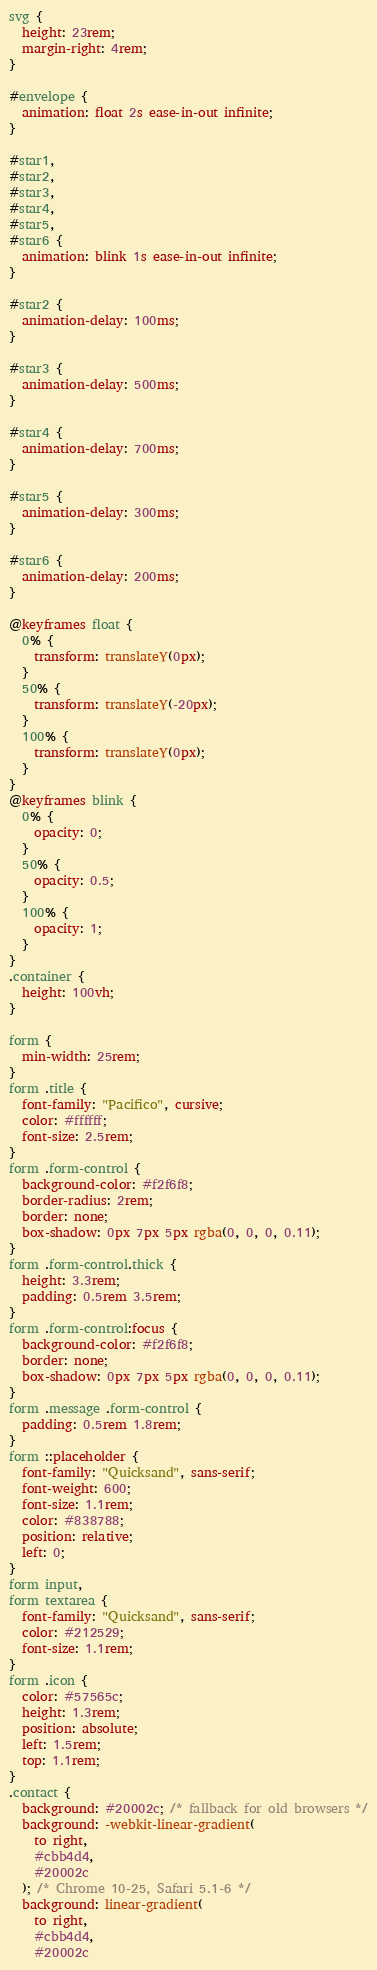Convert code to text. <code><loc_0><loc_0><loc_500><loc_500><_CSS_>svg {
  height: 23rem;
  margin-right: 4rem;
}

#envelope {
  animation: float 2s ease-in-out infinite;
}

#star1,
#star2,
#star3,
#star4,
#star5,
#star6 {
  animation: blink 1s ease-in-out infinite;
}

#star2 {
  animation-delay: 100ms;
}

#star3 {
  animation-delay: 500ms;
}

#star4 {
  animation-delay: 700ms;
}

#star5 {
  animation-delay: 300ms;
}

#star6 {
  animation-delay: 200ms;
}

@keyframes float {
  0% {
    transform: translateY(0px);
  }
  50% {
    transform: translateY(-20px);
  }
  100% {
    transform: translateY(0px);
  }
}
@keyframes blink {
  0% {
    opacity: 0;
  }
  50% {
    opacity: 0.5;
  }
  100% {
    opacity: 1;
  }
}
.container {
  height: 100vh;
}

form {
  min-width: 25rem;
}
form .title {
  font-family: "Pacifico", cursive;
  color: #ffffff;
  font-size: 2.5rem;
}
form .form-control {
  background-color: #f2f6f8;
  border-radius: 2rem;
  border: none;
  box-shadow: 0px 7px 5px rgba(0, 0, 0, 0.11);
}
form .form-control.thick {
  height: 3.3rem;
  padding: 0.5rem 3.5rem;
}
form .form-control:focus {
  background-color: #f2f6f8;
  border: none;
  box-shadow: 0px 7px 5px rgba(0, 0, 0, 0.11);
}
form .message .form-control {
  padding: 0.5rem 1.8rem;
}
form ::placeholder {
  font-family: "Quicksand", sans-serif;
  font-weight: 600;
  font-size: 1.1rem;
  color: #838788;
  position: relative;
  left: 0;
}
form input,
form textarea {
  font-family: "Quicksand", sans-serif;
  color: #212529;
  font-size: 1.1rem;
}
form .icon {
  color: #57565c;
  height: 1.3rem;
  position: absolute;
  left: 1.5rem;
  top: 1.1rem;
}
.contact {
  background: #20002c; /* fallback for old browsers */
  background: -webkit-linear-gradient(
    to right,
    #cbb4d4,
    #20002c
  ); /* Chrome 10-25, Safari 5.1-6 */
  background: linear-gradient(
    to right,
    #cbb4d4,
    #20002c</code> 